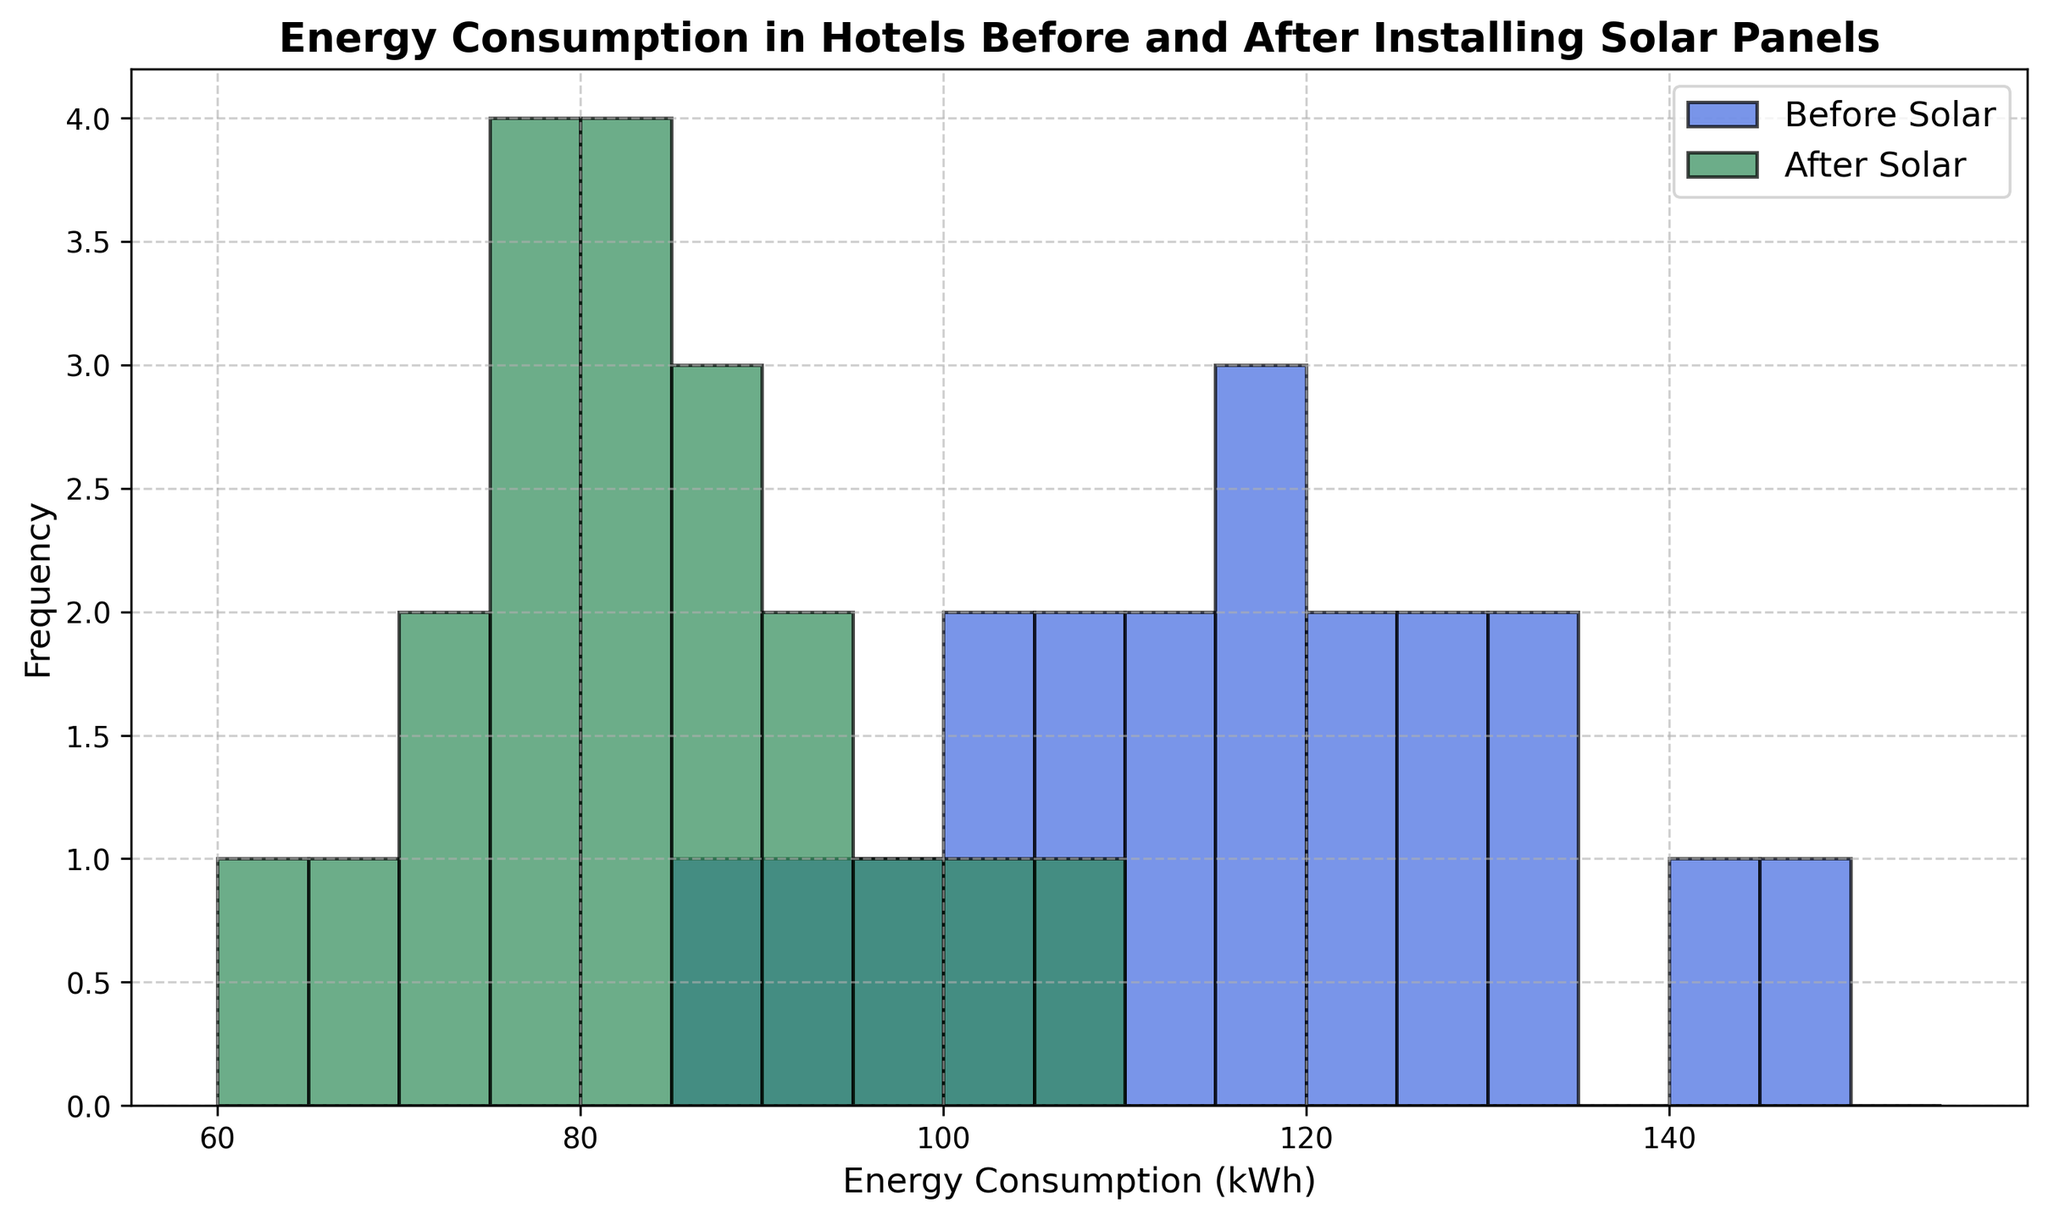What range of energy consumption values seems most frequent for hotels before installing solar panels? By looking at the height of the bars, the range of energy consumption values between 100 and 120 kWh has the tallest bars, indicating that it is the most frequent range.
Answer: 100-120 kWh How does the distribution of energy consumption change after installing solar panels? After installing solar panels, the histogram shows a visible shift to the left, with the most frequent energy consumption values now mainly ranging from 70 to 90 kWh. This indicates a reduction in energy consumption.
Answer: Shifts left, 70-90 kWh What is the impact on the highest recorded energy consumption before and after the installation of solar panels? The highest recorded energy consumption before installing solar panels is 145 kWh. After installation, it reduces to 105 kWh. This shows a maximum reduction in energy consumption of 40 kWh.
Answer: Decreased from 145 kWh to 105 kWh What is the difference in the frequency of energy consumption at around 110 kWh before and after installing solar panels? The histogram shows that before solar panel installation, 110 kWh is relatively frequent, whereas after installation, the frequency decreases significantly, with very few occurrences around 110 kWh.
Answer: Significantly decreased Which range of energy consumption shows the greatest reduction in frequency after installing solar panels? The range of 90-110 kWh shows the greatest reduction in frequency, as this range had numerous occurrences before installation and significantly fewer after.
Answer: 90-110 kWh Which histogram color represents the energy consumption after installing solar panels, and how can you tell? The histogram representing energy consumption after installing solar panels is colored in seagreen. This can be inferred from the legend in the plot.
Answer: Seagreen What is the general trend observed in the energy consumption pattern after the installation of solar panels? The general trend indicates a reduction in energy consumption post-installation, as most of the data shifts towards lower values in the histogram after installing solar panels.
Answer: Reduction in energy consumption Are there any energy consumption values that appear in both histograms with similar frequency? Energy consumption values around 100 and 120 kWh have similar frequencies in both histograms, indicating little to no difference in frequency for these specific values.
Answer: 100 and 120 kWh What can be inferred from the height of the bars for the energy consumption range of 95 to 105 kWh before and after solar panel installation? Before solar panel installation, the 95-105 kWh range has prominent bars indicating higher frequency. After installation, these values have reduced frequency, with shorter bars. This implies a notable decrease in energy usage around this range.
Answer: Decreased frequency Which histogram (before or after solar panel installation) has a wider spread of energy consumption values? The 'Before Solar' histogram has a wider spread of energy consumption values ranging from 85 to 145 kWh, compared to the 'After Solar' histogram, which ranges from 62 to 105 kWh.
Answer: Before Solar 